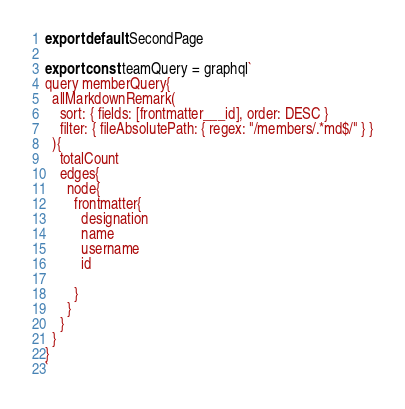<code> <loc_0><loc_0><loc_500><loc_500><_JavaScript_>export default SecondPage

export const teamQuery = graphql`
query memberQuery{
  allMarkdownRemark(
    sort: { fields: [frontmatter___id], order: DESC }
    filter: { fileAbsolutePath: { regex: "/members/.*md$/" } }
  ){
    totalCount
    edges{
      node{
        frontmatter{
          designation
          name
          username
          id
         
        }
      }
    }
  }
}
`

</code> 